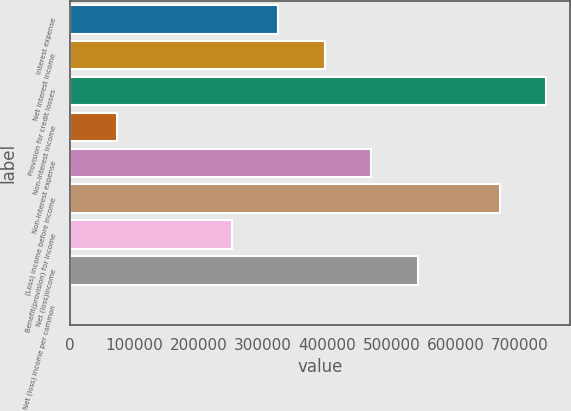Convert chart to OTSL. <chart><loc_0><loc_0><loc_500><loc_500><bar_chart><fcel>Interest expense<fcel>Net interest income<fcel>Provision for credit losses<fcel>Non-interest income<fcel>Non-interest expense<fcel>(Loss) income before income<fcel>Benefit(provision) for income<fcel>Net (loss)income<fcel>Net (loss) income per common<nl><fcel>324210<fcel>396470<fcel>741499<fcel>72261.9<fcel>468731<fcel>669238<fcel>251949<fcel>540992<fcel>1.2<nl></chart> 